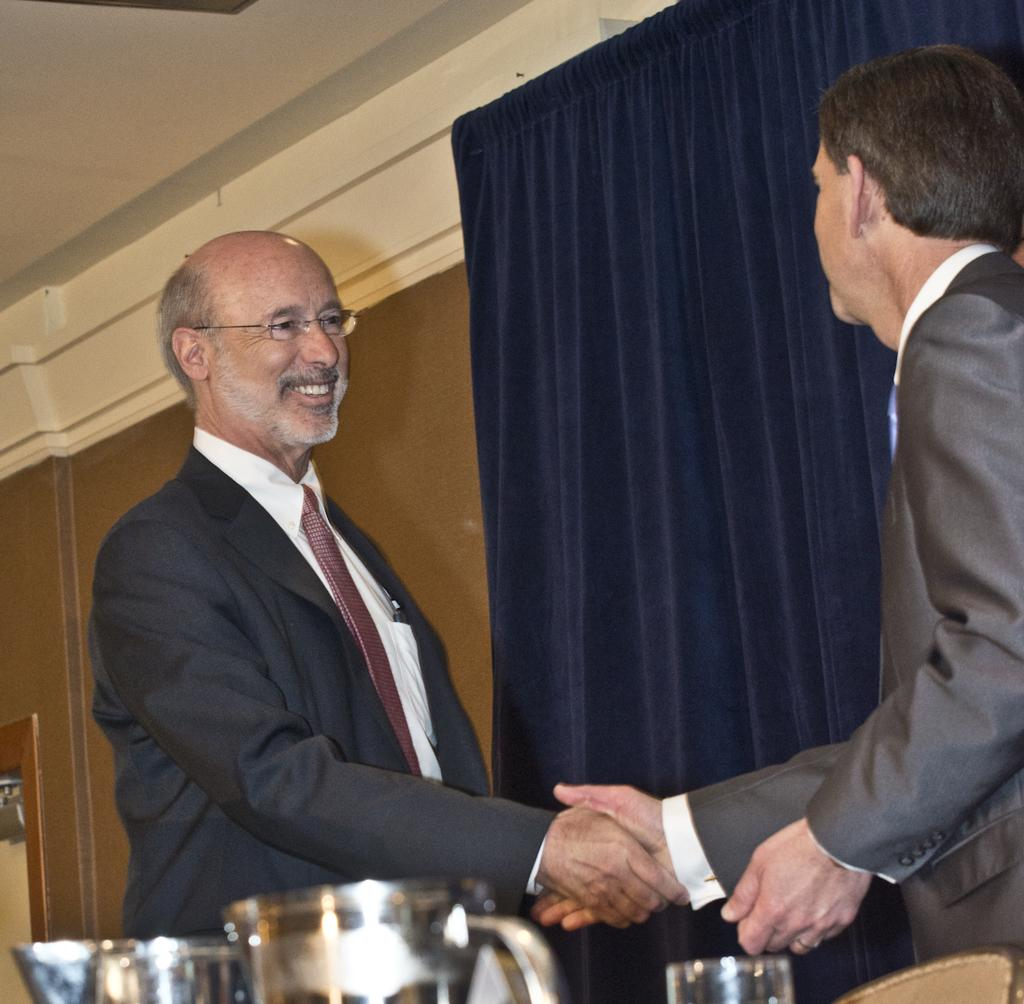How many people are in the image? There are two persons in the image. What are the two persons wearing? The two persons are wearing coats. What action are the two persons performing? The two persons are shaking hands. What type of window treatment is visible in the image? There is a curtain visible in the image. What type of joke is being told by the unit in the image? There is no unit or joke present in the image; it features two persons shaking hands while wearing coats. 